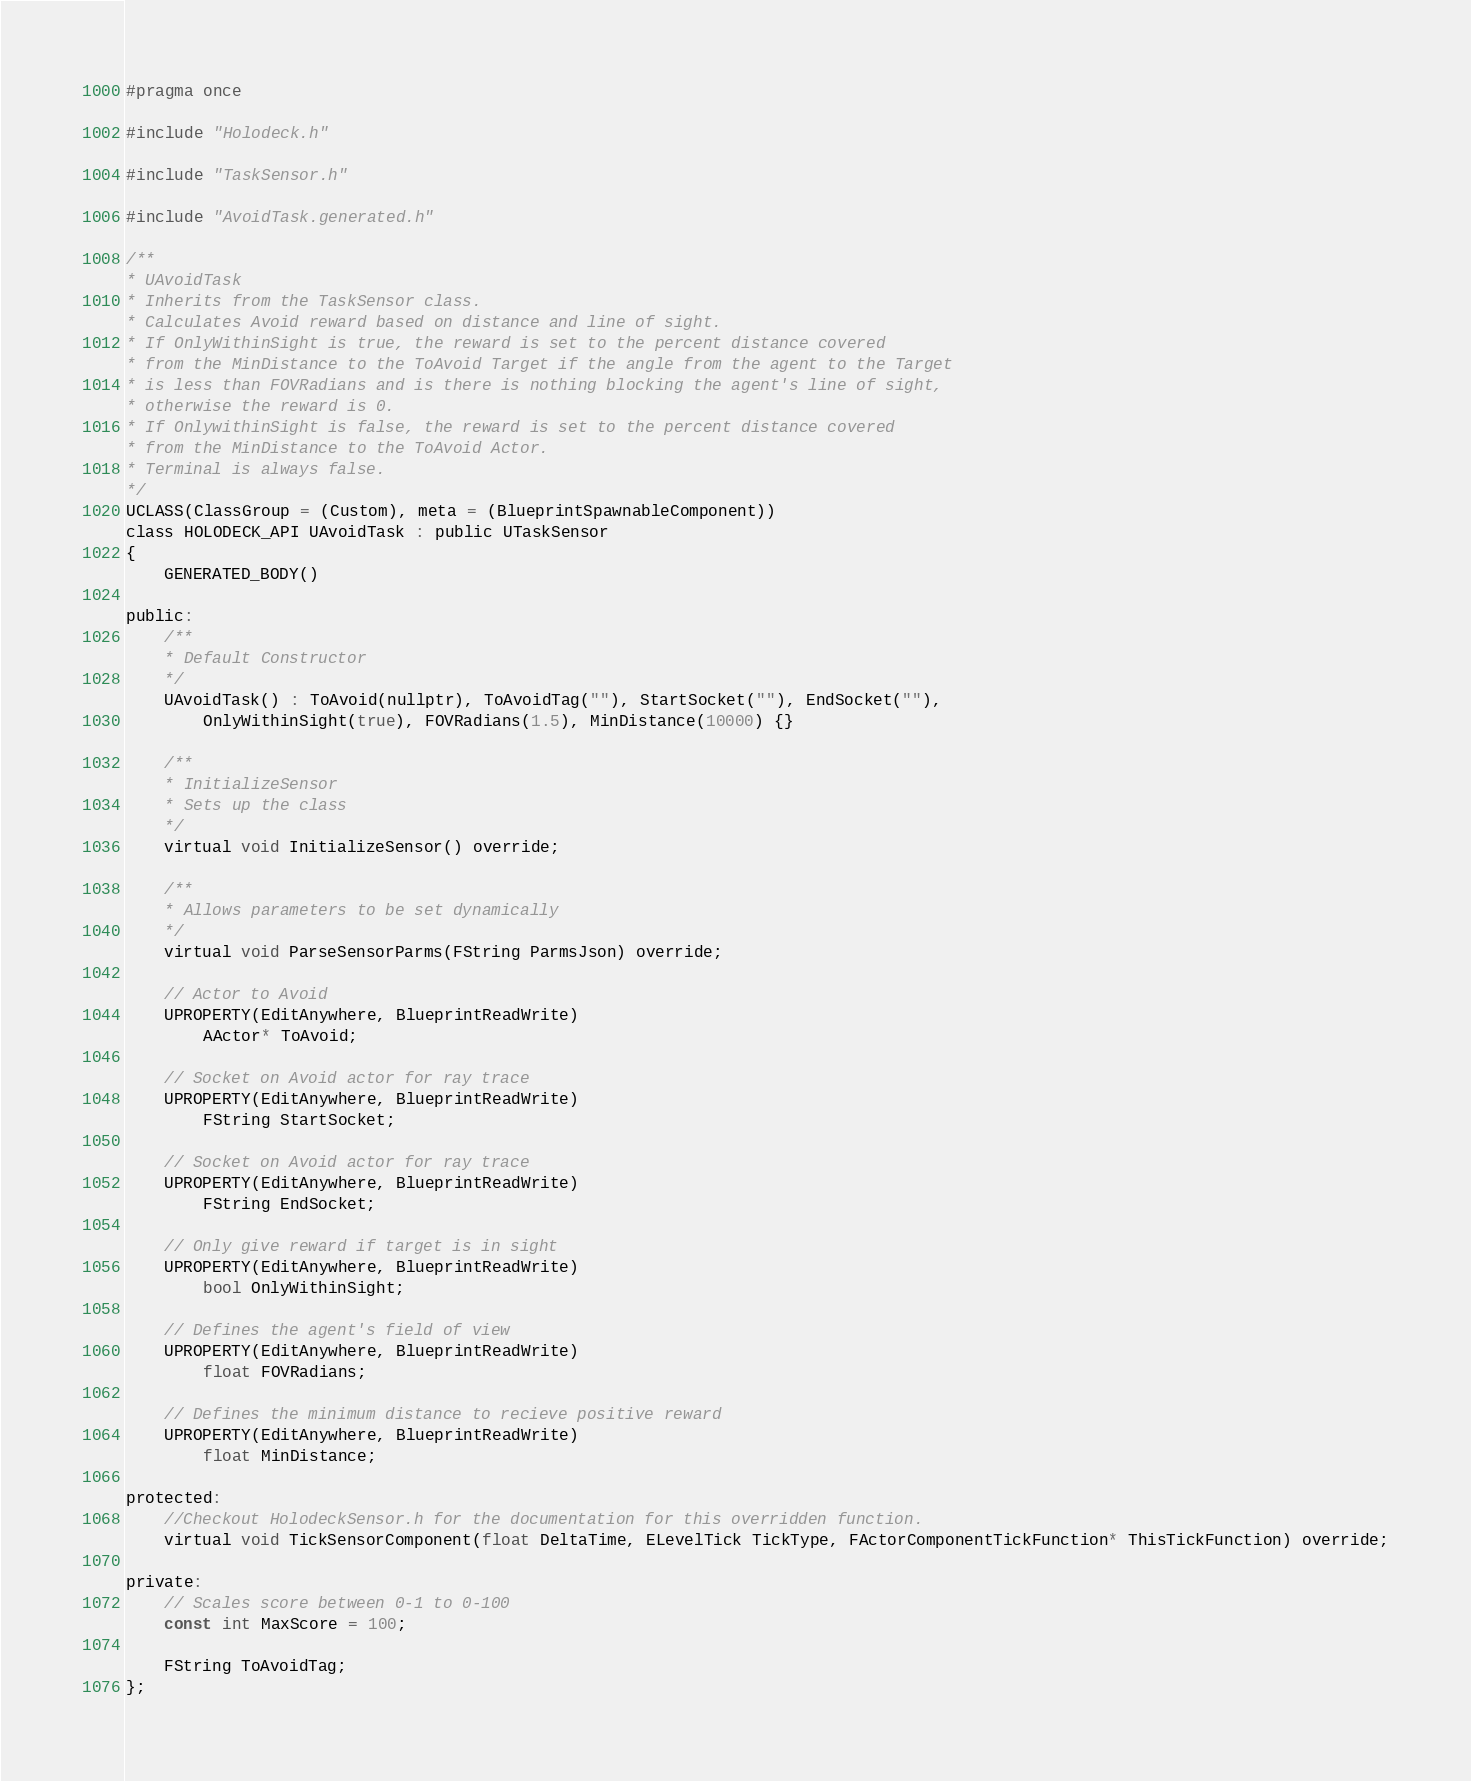<code> <loc_0><loc_0><loc_500><loc_500><_C_>#pragma once

#include "Holodeck.h"

#include "TaskSensor.h"

#include "AvoidTask.generated.h"

/**
* UAvoidTask
* Inherits from the TaskSensor class.
* Calculates Avoid reward based on distance and line of sight.
* If OnlyWithinSight is true, the reward is set to the percent distance covered
* from the MinDistance to the ToAvoid Target if the angle from the agent to the Target
* is less than FOVRadians and is there is nothing blocking the agent's line of sight,
* otherwise the reward is 0.
* If OnlywithinSight is false, the reward is set to the percent distance covered
* from the MinDistance to the ToAvoid Actor.
* Terminal is always false.
*/
UCLASS(ClassGroup = (Custom), meta = (BlueprintSpawnableComponent))
class HOLODECK_API UAvoidTask : public UTaskSensor
{
	GENERATED_BODY()

public:
	/**
	* Default Constructor
	*/
	UAvoidTask() : ToAvoid(nullptr), ToAvoidTag(""), StartSocket(""), EndSocket(""),
		OnlyWithinSight(true), FOVRadians(1.5), MinDistance(10000) {}

	/**
	* InitializeSensor
	* Sets up the class
	*/
	virtual void InitializeSensor() override;

	/**
	* Allows parameters to be set dynamically
	*/
	virtual void ParseSensorParms(FString ParmsJson) override;

	// Actor to Avoid
	UPROPERTY(EditAnywhere, BlueprintReadWrite)
		AActor* ToAvoid;

	// Socket on Avoid actor for ray trace
	UPROPERTY(EditAnywhere, BlueprintReadWrite)
		FString StartSocket;

	// Socket on Avoid actor for ray trace
	UPROPERTY(EditAnywhere, BlueprintReadWrite)
		FString EndSocket;

	// Only give reward if target is in sight
	UPROPERTY(EditAnywhere, BlueprintReadWrite)
		bool OnlyWithinSight;

	// Defines the agent's field of view
	UPROPERTY(EditAnywhere, BlueprintReadWrite)
		float FOVRadians;

	// Defines the minimum distance to recieve positive reward
	UPROPERTY(EditAnywhere, BlueprintReadWrite)
		float MinDistance;

protected:
	//Checkout HolodeckSensor.h for the documentation for this overridden function.
	virtual void TickSensorComponent(float DeltaTime, ELevelTick TickType, FActorComponentTickFunction* ThisTickFunction) override;

private:
	// Scales score between 0-1 to 0-100
	const int MaxScore = 100;

	FString ToAvoidTag;
};
</code> 